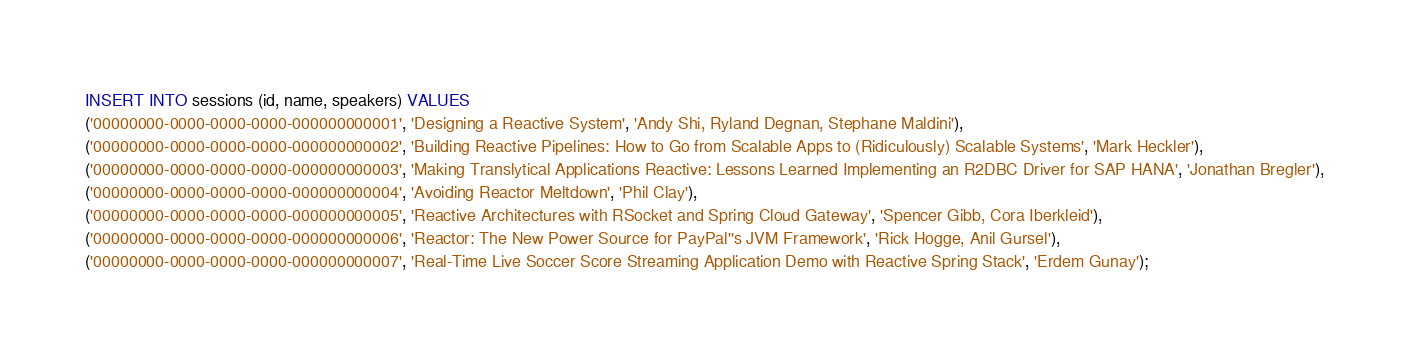<code> <loc_0><loc_0><loc_500><loc_500><_SQL_>INSERT INTO sessions (id, name, speakers) VALUES
('00000000-0000-0000-0000-000000000001', 'Designing a Reactive System', 'Andy Shi, Ryland Degnan, Stephane Maldini'),
('00000000-0000-0000-0000-000000000002', 'Building Reactive Pipelines: How to Go from Scalable Apps to (Ridiculously) Scalable Systems', 'Mark Heckler'),
('00000000-0000-0000-0000-000000000003', 'Making Translytical Applications Reactive: Lessons Learned Implementing an R2DBC Driver for SAP HANA', 'Jonathan Bregler'),
('00000000-0000-0000-0000-000000000004', 'Avoiding Reactor Meltdown', 'Phil Clay'),
('00000000-0000-0000-0000-000000000005', 'Reactive Architectures with RSocket and Spring Cloud Gateway', 'Spencer Gibb, Cora Iberkleid'),
('00000000-0000-0000-0000-000000000006', 'Reactor: The New Power Source for PayPal''s JVM Framework', 'Rick Hogge, Anil Gursel'),
('00000000-0000-0000-0000-000000000007', 'Real-Time Live Soccer Score Streaming Application Demo with Reactive Spring Stack', 'Erdem Gunay');
</code> 